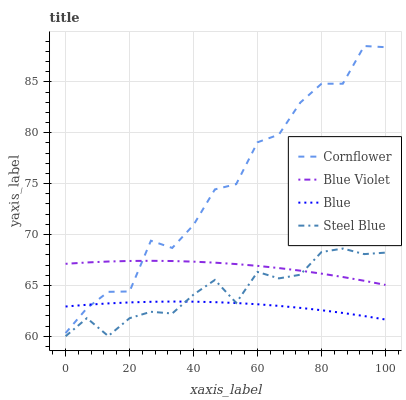Does Blue have the minimum area under the curve?
Answer yes or no. Yes. Does Cornflower have the maximum area under the curve?
Answer yes or no. Yes. Does Steel Blue have the minimum area under the curve?
Answer yes or no. No. Does Steel Blue have the maximum area under the curve?
Answer yes or no. No. Is Blue the smoothest?
Answer yes or no. Yes. Is Cornflower the roughest?
Answer yes or no. Yes. Is Steel Blue the smoothest?
Answer yes or no. No. Is Steel Blue the roughest?
Answer yes or no. No. Does Steel Blue have the lowest value?
Answer yes or no. Yes. Does Cornflower have the lowest value?
Answer yes or no. No. Does Cornflower have the highest value?
Answer yes or no. Yes. Does Steel Blue have the highest value?
Answer yes or no. No. Is Steel Blue less than Cornflower?
Answer yes or no. Yes. Is Cornflower greater than Steel Blue?
Answer yes or no. Yes. Does Cornflower intersect Blue?
Answer yes or no. Yes. Is Cornflower less than Blue?
Answer yes or no. No. Is Cornflower greater than Blue?
Answer yes or no. No. Does Steel Blue intersect Cornflower?
Answer yes or no. No. 